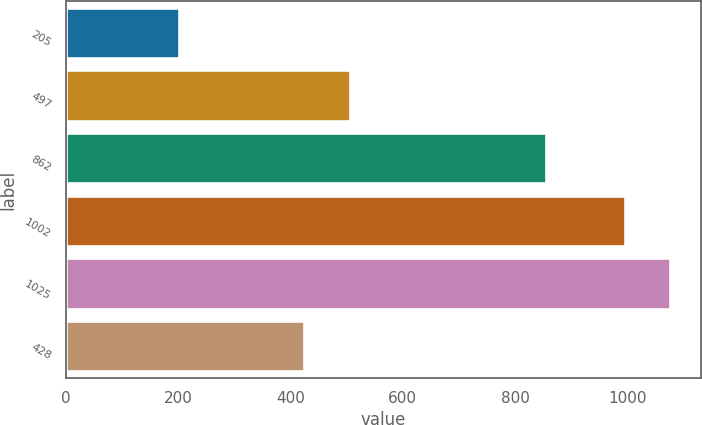Convert chart to OTSL. <chart><loc_0><loc_0><loc_500><loc_500><bar_chart><fcel>205<fcel>497<fcel>862<fcel>1002<fcel>1025<fcel>428<nl><fcel>202<fcel>505.1<fcel>855<fcel>995<fcel>1076.1<fcel>424<nl></chart> 